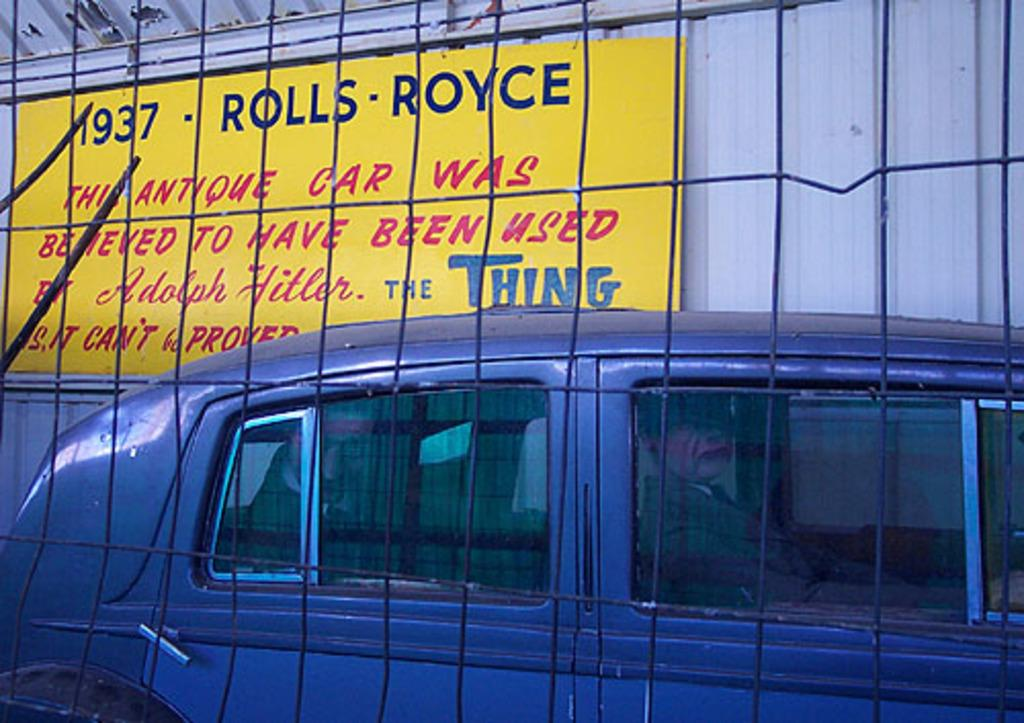What is the main subject in the image? There is a vehicle in the image. What can be seen in the background of the image? There is a board and a shed in the background of the image. What is present in the foreground of the image? There is a mesh in the foreground of the image. What type of theory is being discussed by the chicken and cattle in the image? There are no chicken or cattle present in the image, and therefore no discussion of any theory can be observed. 